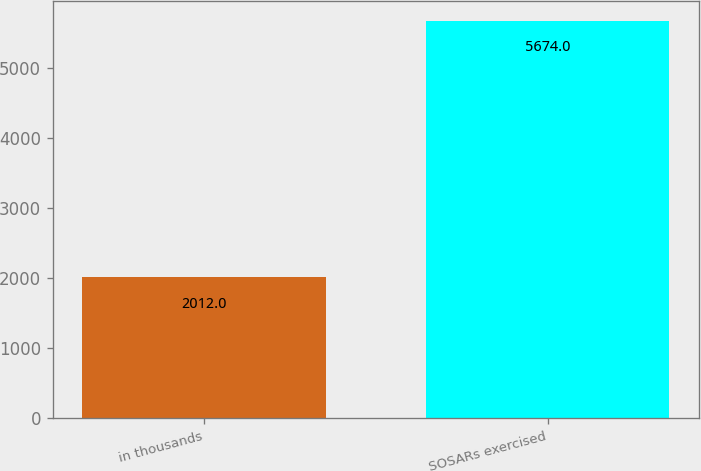Convert chart. <chart><loc_0><loc_0><loc_500><loc_500><bar_chart><fcel>in thousands<fcel>SOSARs exercised<nl><fcel>2012<fcel>5674<nl></chart> 